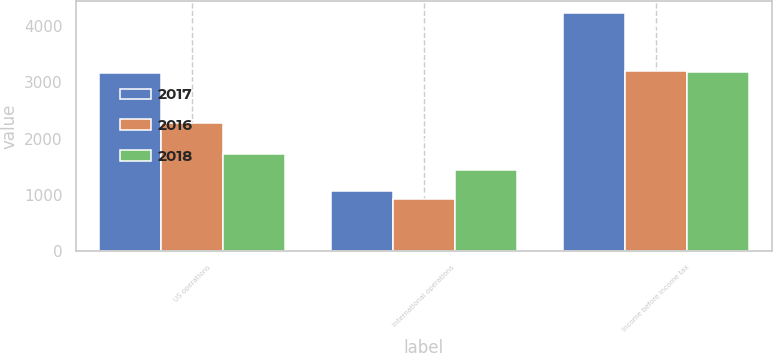<chart> <loc_0><loc_0><loc_500><loc_500><stacked_bar_chart><ecel><fcel>US operations<fcel>International operations<fcel>Income before income tax<nl><fcel>2017<fcel>3168<fcel>1064<fcel>4232<nl><fcel>2016<fcel>2283<fcel>924<fcel>3207<nl><fcel>2018<fcel>1733<fcel>1449<fcel>3182<nl></chart> 